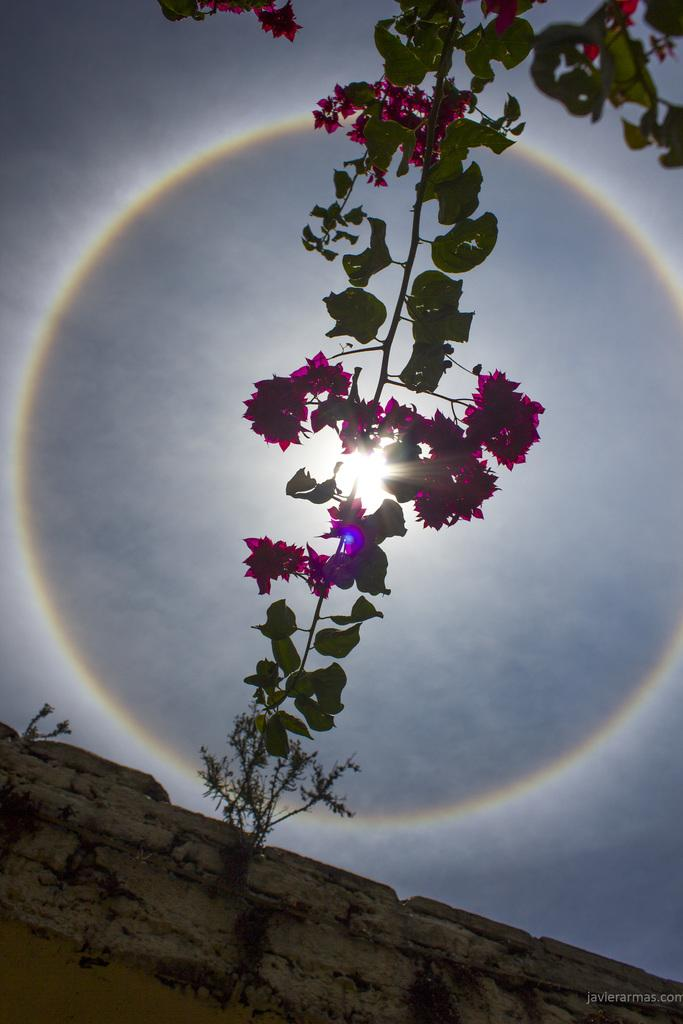What is the main subject of the image? The main subject of the image is a stem with flowers and leaves. Are there any other plants visible in the image? Yes, there are plants on the wall in the image. What can be seen in the background of the image? The background of the image includes the sky. What celestial body is visible in the sky? The sun is visible in the sky. How many passengers are visible in the image? There are no passengers present in the image. How long does it take for the flowers to bloom in the image? The image does not provide information about the time it takes for the flowers to bloom. 